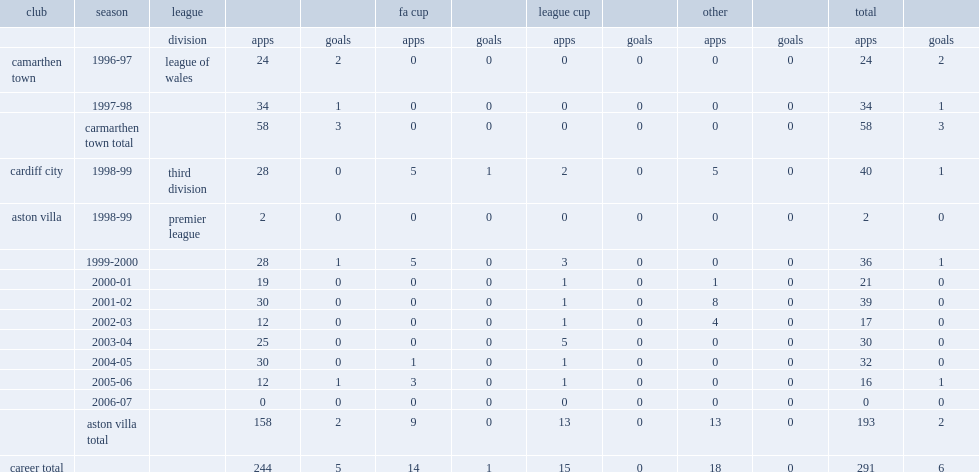What was the number of apps for aston villa made by mark delaney? 193.0. 